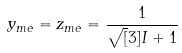<formula> <loc_0><loc_0><loc_500><loc_500>y _ { m e } = z _ { m e } = \frac { 1 } { \sqrt { [ } 3 ] { I } + 1 }</formula> 